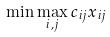Convert formula to latex. <formula><loc_0><loc_0><loc_500><loc_500>\min \max _ { i , j } c _ { i j } x _ { i j }</formula> 